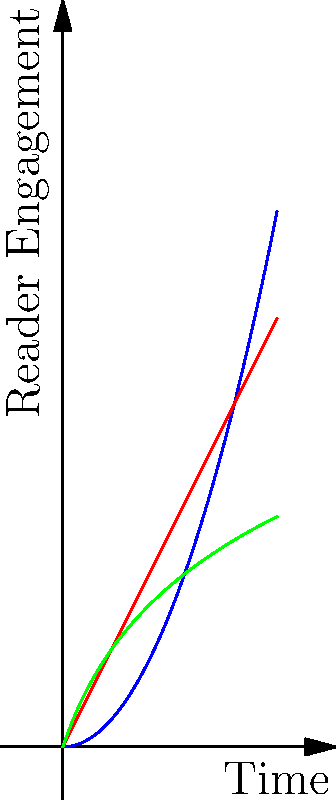In the context of plot structures and their impact on reader engagement over time, which of the following structures is most likely to maintain sustained reader interest throughout a long-form narrative, such as a novel series? To answer this question, let's analyze each plot structure represented in the graph:

1. Blue curve (Exponential Growth): This represents a plot structure where reader engagement increases rapidly over time. While initially captivating, it may be difficult to sustain in a long-form narrative without risking reader burnout or unrealistic plot escalation.

2. Red line (Linear Growth): This shows a steady, consistent increase in reader engagement. It's more sustainable than exponential growth but may lack the periodic intensity that keeps readers highly invested.

3. Green curve (Logarithmic Growth): This structure shows rapid initial growth in reader engagement, followed by a more gradual increase over time. It combines the benefits of early hook and sustained interest.

For a long-form narrative like a novel series:

- The logarithmic growth model (green curve) is most suitable because it:
  a) Provides a strong initial hook to capture reader interest
  b) Allows for periodic intensification of engagement
  c) Maintains a steady, sustainable growth in engagement over time

This structure aligns with common storytelling techniques like introducing compelling conflicts early, developing character arcs, and gradually unveiling complex plot elements, which are essential for maintaining reader interest in extended narratives.
Answer: Logarithmic growth (green curve) 